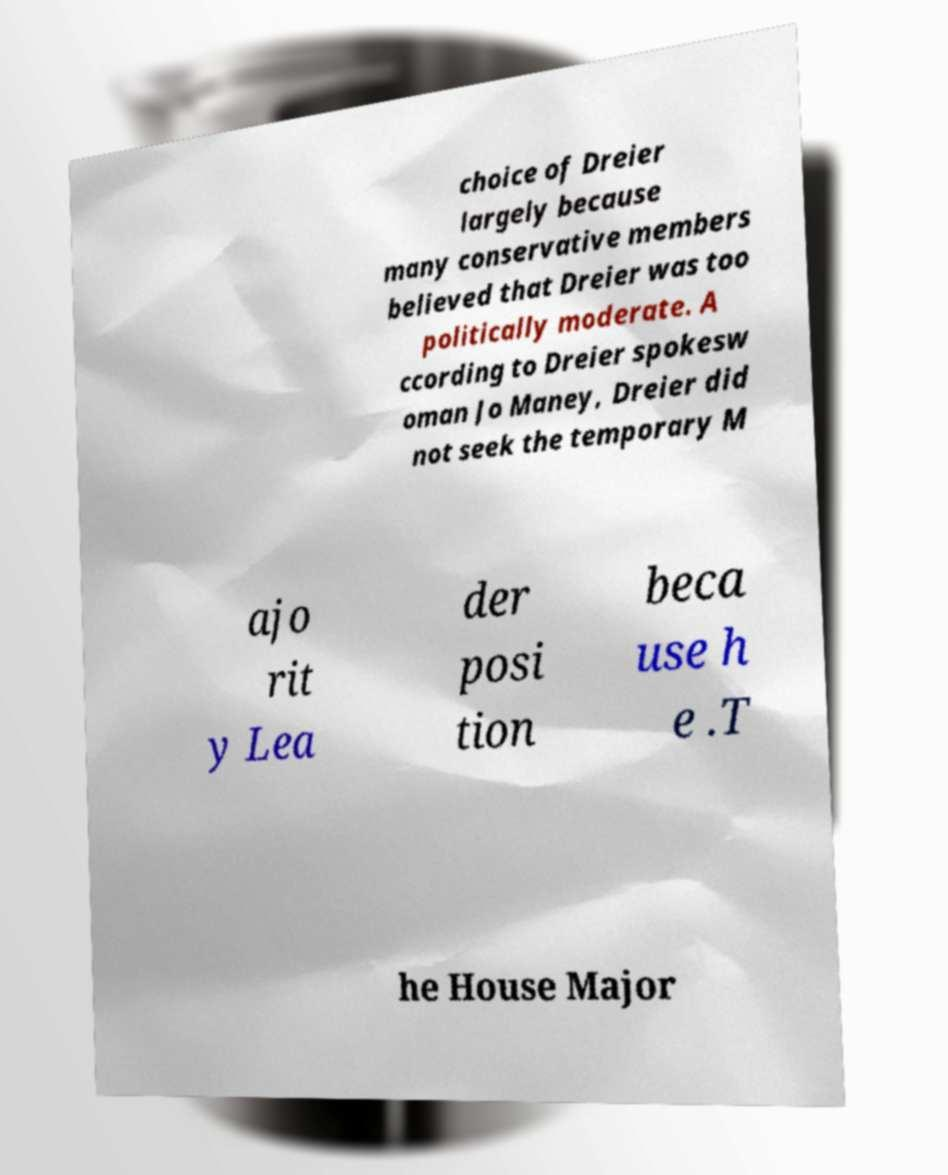Could you extract and type out the text from this image? choice of Dreier largely because many conservative members believed that Dreier was too politically moderate. A ccording to Dreier spokesw oman Jo Maney, Dreier did not seek the temporary M ajo rit y Lea der posi tion beca use h e .T he House Major 